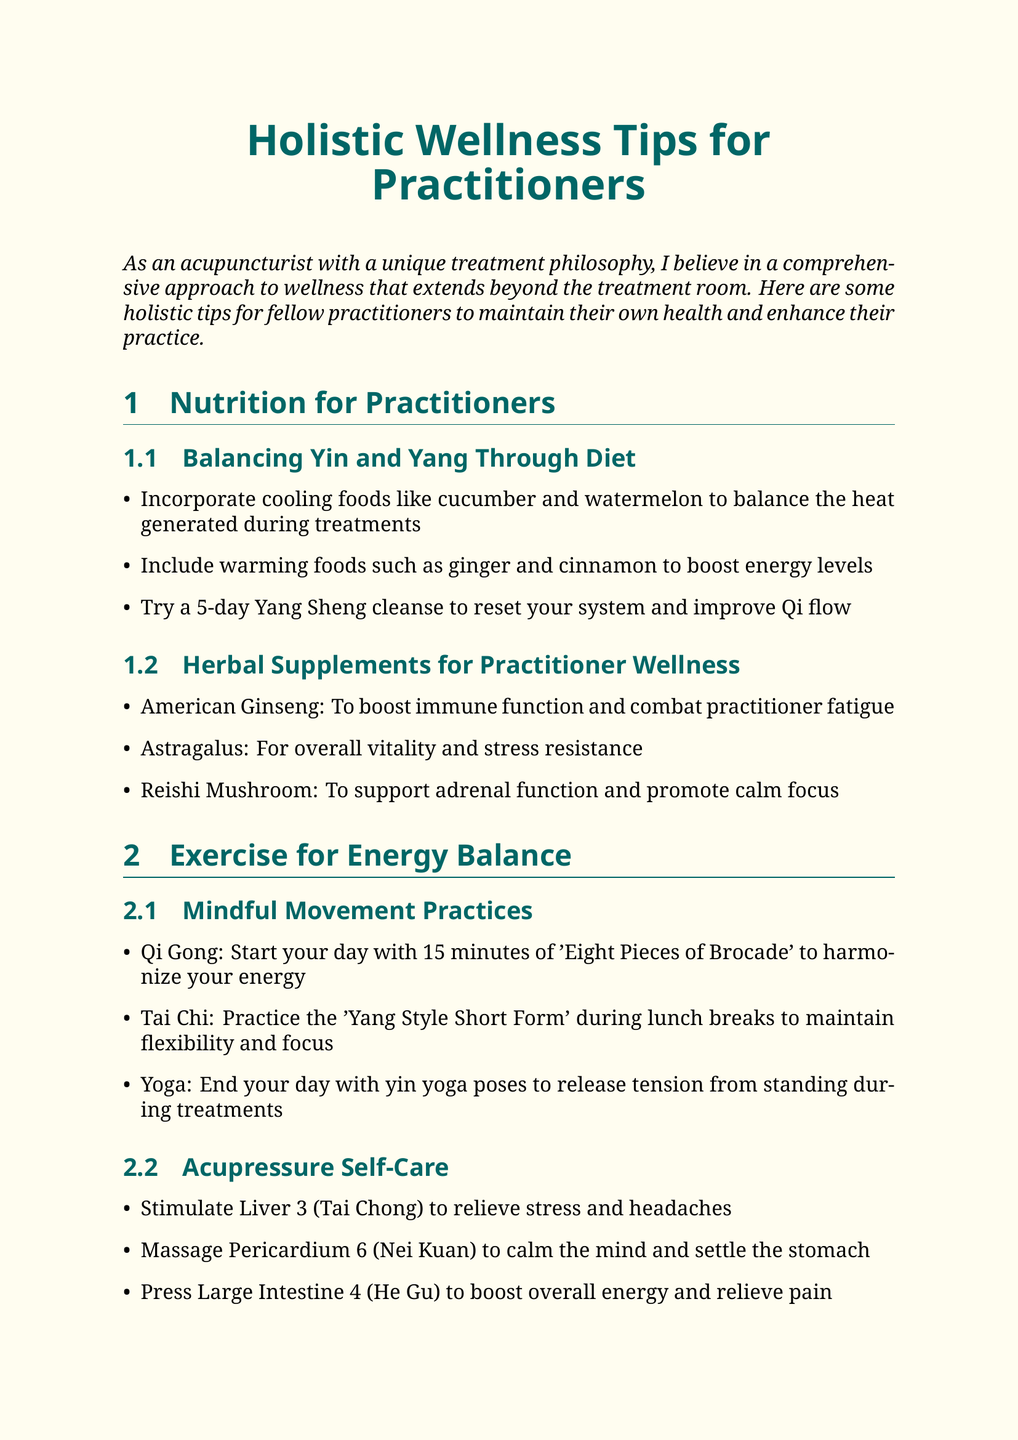What are cooling foods mentioned in the document? The document lists cooling foods that practitioners can incorporate into their diets, such as cucumber and watermelon.
Answer: cucumber and watermelon What is the purpose of American Ginseng? American Ginseng is specifically recommended for enhancing immune function and reducing practitioner fatigue.
Answer: boost immune function and combat practitioner fatigue Which exercise is suggested for flexibility during lunch breaks? The document offers Tai Chi as an exercise to practice during lunch breaks to maintain flexibility and focus.
Answer: Tai Chi What meditation is recommended for cultivating positive energy? The 'Inner Smile' meditation from Taoist traditions is suggested for fostering positive energy.
Answer: Inner Smile How many minutes of Qi Gong should practitioners start their day with? The document states that practitioners should start their day with 15 minutes of Qi Gong, specifically the 'Eight Pieces of Brocade.'
Answer: 15 minutes What type of oils can create a calming environment in treatment rooms? Lavender and bergamot essential oils are mentioned as beneficial for creating a calming atmosphere in treatment rooms.
Answer: lavender or bergamot Which acupressure point helps relieve stress and headaches? The document mentions stimulating Liver 3 (Tai Chong) as a way to help alleviate stress and headaches.
Answer: Liver 3 (Tai Chong) What annual event should practitioners attend to learn about complementary wellness approaches? The document encourages practitioners to attend the annual 'Integrative Healthcare Symposium' for learning about complementary wellness.
Answer: Integrative Healthcare Symposium 